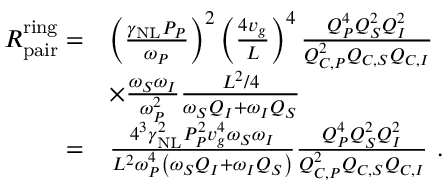<formula> <loc_0><loc_0><loc_500><loc_500>\begin{array} { r l } { R _ { p a i r } ^ { r i n g } = } & { \left ( \frac { \gamma _ { N L } P _ { P } } { \omega _ { P } } \right ) ^ { 2 } \left ( \frac { 4 v _ { g } } { L } \right ) ^ { 4 } \frac { Q _ { P } ^ { 4 } Q _ { S } ^ { 2 } Q _ { I } ^ { 2 } } { Q _ { C , P } ^ { 2 } Q _ { C , S } Q _ { C , I } } } \\ & { \times \frac { \omega _ { S } \omega _ { I } } { \omega _ { P } ^ { 2 } } \frac { L ^ { 2 } / 4 } { \omega _ { S } Q _ { I } + \omega _ { I } Q _ { S } } } \\ { = } & { \frac { 4 ^ { 3 } \gamma _ { N L } ^ { 2 } P _ { P } ^ { 2 } v _ { g } ^ { 4 } \omega _ { S } \omega _ { I } } { L ^ { 2 } \omega _ { P } ^ { 4 } \left ( \omega _ { S } Q _ { I } + \omega _ { I } Q _ { S } \right ) } \frac { Q _ { P } ^ { 4 } Q _ { S } ^ { 2 } Q _ { I } ^ { 2 } } { Q _ { C , P } ^ { 2 } Q _ { C , S } Q _ { C , I } } \ . } \end{array}</formula> 